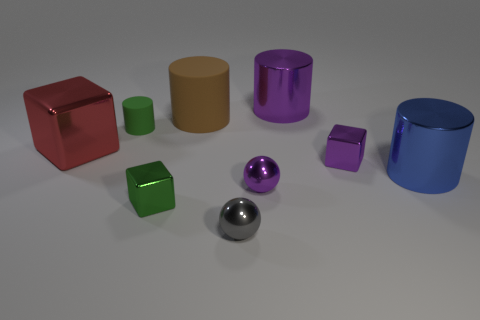What number of things are large cylinders that are to the left of the gray sphere or small metallic blocks?
Your answer should be compact. 3. Is the tiny purple cube made of the same material as the small green thing in front of the tiny green cylinder?
Keep it short and to the point. Yes. The shiny object that is the same color as the small matte object is what size?
Make the answer very short. Small. Are there any big cyan cylinders that have the same material as the purple cylinder?
Provide a succinct answer. No. What number of objects are either rubber things on the right side of the small green metallic thing or objects left of the small matte cylinder?
Ensure brevity in your answer.  2. There is a tiny gray metallic thing; is its shape the same as the purple metal thing that is left of the large purple shiny cylinder?
Ensure brevity in your answer.  Yes. How many other things are there of the same shape as the blue thing?
Give a very brief answer. 3. How many objects are either purple spheres or gray shiny balls?
Provide a short and direct response. 2. There is a tiny purple object that is in front of the large object that is in front of the large cube; what shape is it?
Your answer should be very brief. Sphere. Is the number of tiny matte cylinders less than the number of metallic cubes?
Make the answer very short. Yes. 